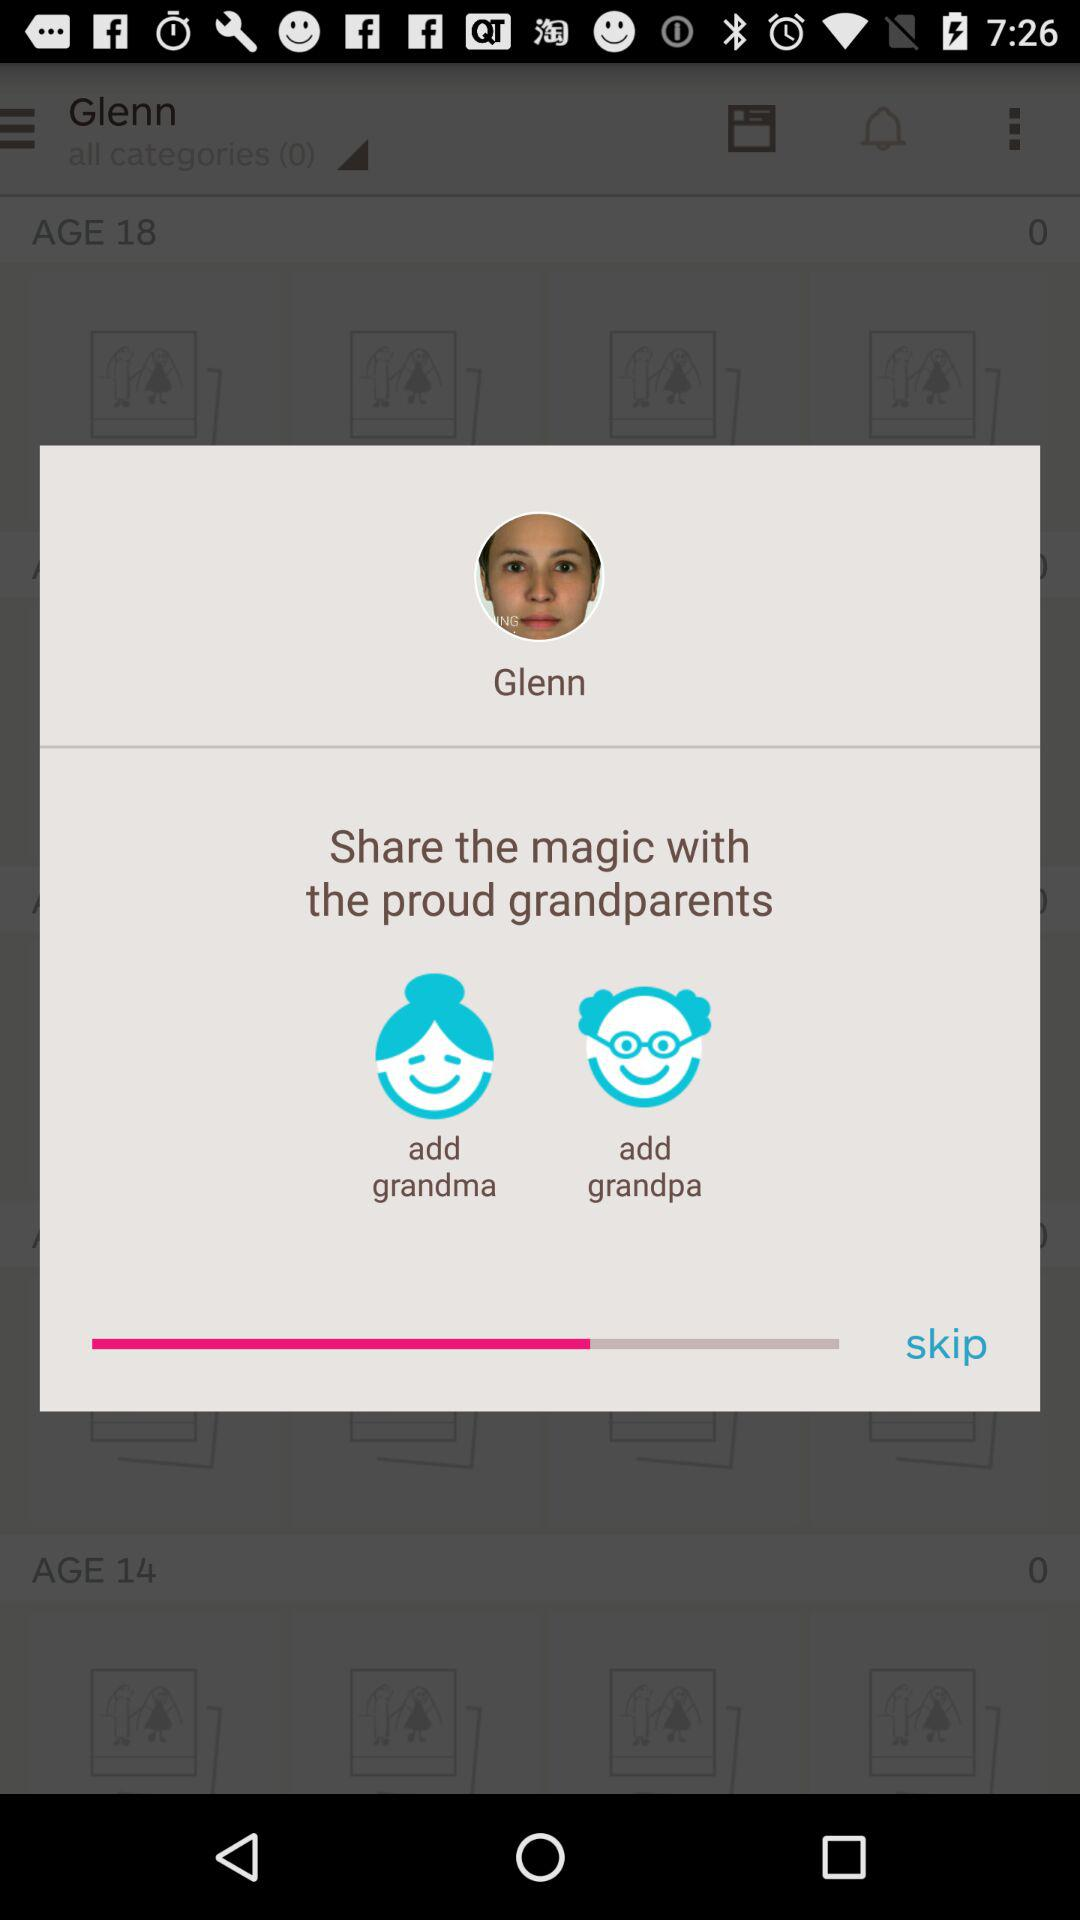What's the user's profile name? The user's profile name is Glenn. 